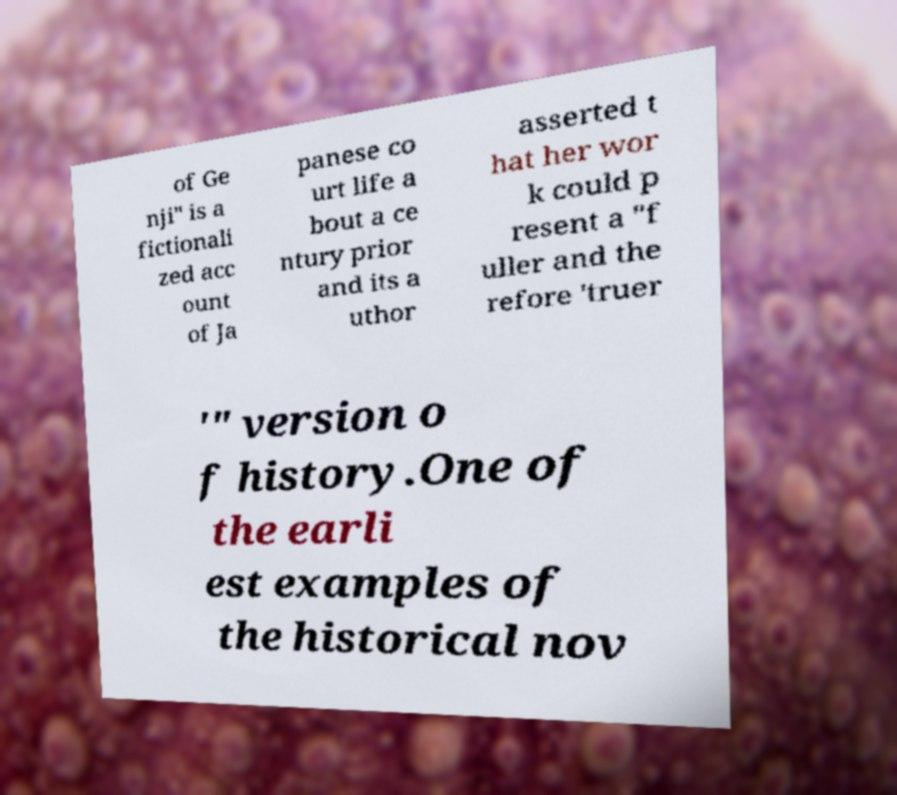Can you accurately transcribe the text from the provided image for me? of Ge nji" is a fictionali zed acc ount of Ja panese co urt life a bout a ce ntury prior and its a uthor asserted t hat her wor k could p resent a "f uller and the refore 'truer '" version o f history.One of the earli est examples of the historical nov 